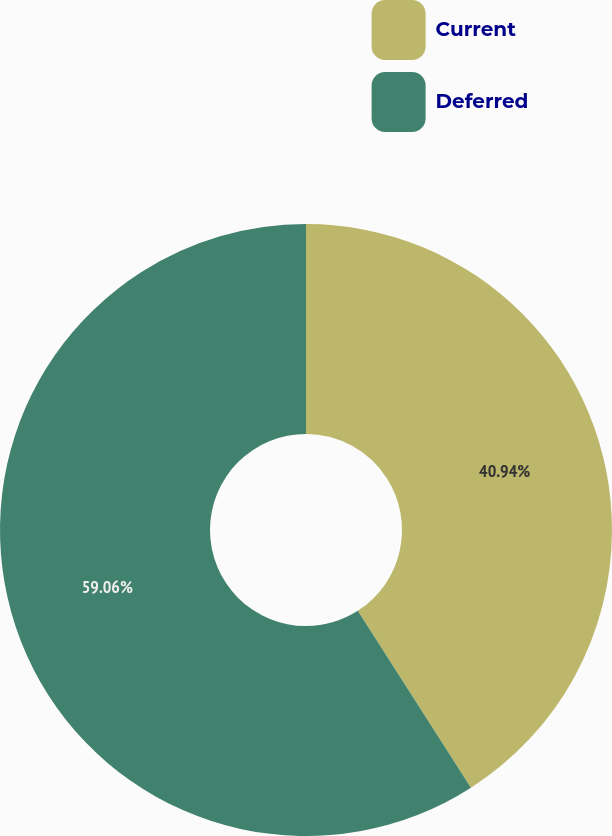Convert chart to OTSL. <chart><loc_0><loc_0><loc_500><loc_500><pie_chart><fcel>Current<fcel>Deferred<nl><fcel>40.94%<fcel>59.06%<nl></chart> 